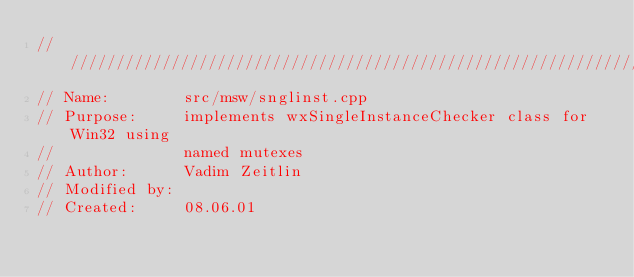Convert code to text. <code><loc_0><loc_0><loc_500><loc_500><_C++_>///////////////////////////////////////////////////////////////////////////////
// Name:        src/msw/snglinst.cpp
// Purpose:     implements wxSingleInstanceChecker class for Win32 using
//              named mutexes
// Author:      Vadim Zeitlin
// Modified by:
// Created:     08.06.01</code> 